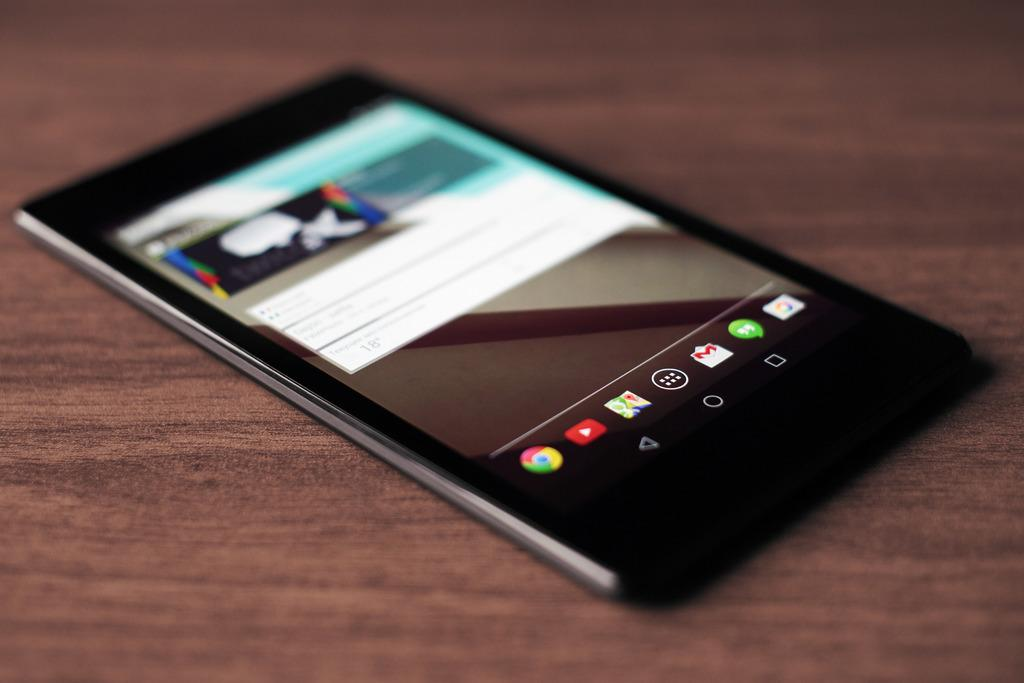What electronic device is visible in the image? There is a mobile phone in the image. Where is the mobile phone located? The mobile phone is on a table. How does the mobile phone contribute to pollution in the image? The image does not provide any information about pollution, and there is no indication that the mobile phone contributes to pollution in the image. 